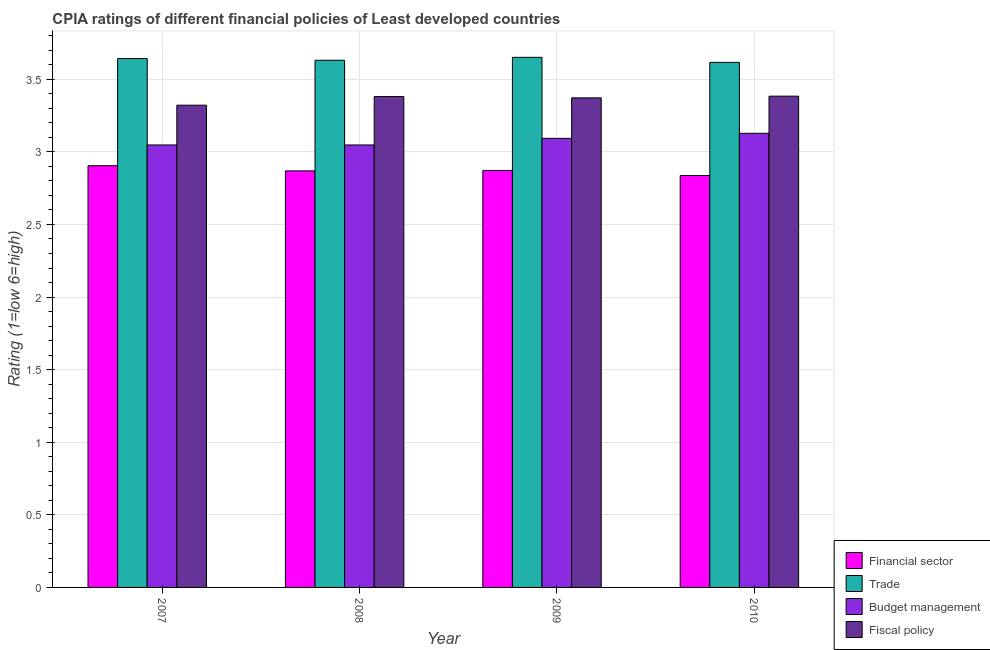How many different coloured bars are there?
Offer a very short reply. 4. How many groups of bars are there?
Your answer should be compact. 4. Are the number of bars per tick equal to the number of legend labels?
Offer a very short reply. Yes. How many bars are there on the 3rd tick from the right?
Ensure brevity in your answer.  4. What is the label of the 1st group of bars from the left?
Ensure brevity in your answer.  2007. What is the cpia rating of budget management in 2010?
Make the answer very short. 3.13. Across all years, what is the maximum cpia rating of financial sector?
Keep it short and to the point. 2.9. Across all years, what is the minimum cpia rating of fiscal policy?
Provide a succinct answer. 3.32. In which year was the cpia rating of trade minimum?
Make the answer very short. 2010. What is the total cpia rating of budget management in the graph?
Provide a short and direct response. 12.32. What is the difference between the cpia rating of budget management in 2008 and that in 2009?
Your answer should be very brief. -0.05. What is the difference between the cpia rating of trade in 2009 and the cpia rating of fiscal policy in 2010?
Keep it short and to the point. 0.03. What is the average cpia rating of trade per year?
Keep it short and to the point. 3.64. What is the ratio of the cpia rating of fiscal policy in 2008 to that in 2009?
Keep it short and to the point. 1. Is the difference between the cpia rating of trade in 2007 and 2009 greater than the difference between the cpia rating of financial sector in 2007 and 2009?
Your response must be concise. No. What is the difference between the highest and the second highest cpia rating of trade?
Offer a terse response. 0.01. What is the difference between the highest and the lowest cpia rating of fiscal policy?
Offer a terse response. 0.06. Is it the case that in every year, the sum of the cpia rating of fiscal policy and cpia rating of trade is greater than the sum of cpia rating of financial sector and cpia rating of budget management?
Offer a very short reply. No. What does the 2nd bar from the left in 2007 represents?
Give a very brief answer. Trade. What does the 2nd bar from the right in 2008 represents?
Offer a very short reply. Budget management. Are all the bars in the graph horizontal?
Offer a very short reply. No. What is the difference between two consecutive major ticks on the Y-axis?
Provide a succinct answer. 0.5. Does the graph contain grids?
Provide a short and direct response. Yes. What is the title of the graph?
Offer a very short reply. CPIA ratings of different financial policies of Least developed countries. Does "Pre-primary schools" appear as one of the legend labels in the graph?
Provide a short and direct response. No. What is the label or title of the Y-axis?
Your answer should be very brief. Rating (1=low 6=high). What is the Rating (1=low 6=high) of Financial sector in 2007?
Offer a very short reply. 2.9. What is the Rating (1=low 6=high) in Trade in 2007?
Provide a succinct answer. 3.64. What is the Rating (1=low 6=high) in Budget management in 2007?
Provide a succinct answer. 3.05. What is the Rating (1=low 6=high) of Fiscal policy in 2007?
Your answer should be very brief. 3.32. What is the Rating (1=low 6=high) in Financial sector in 2008?
Make the answer very short. 2.87. What is the Rating (1=low 6=high) in Trade in 2008?
Your answer should be compact. 3.63. What is the Rating (1=low 6=high) in Budget management in 2008?
Keep it short and to the point. 3.05. What is the Rating (1=low 6=high) in Fiscal policy in 2008?
Ensure brevity in your answer.  3.38. What is the Rating (1=low 6=high) in Financial sector in 2009?
Your answer should be compact. 2.87. What is the Rating (1=low 6=high) of Trade in 2009?
Ensure brevity in your answer.  3.65. What is the Rating (1=low 6=high) of Budget management in 2009?
Your response must be concise. 3.09. What is the Rating (1=low 6=high) in Fiscal policy in 2009?
Offer a terse response. 3.37. What is the Rating (1=low 6=high) in Financial sector in 2010?
Your answer should be very brief. 2.84. What is the Rating (1=low 6=high) in Trade in 2010?
Offer a very short reply. 3.62. What is the Rating (1=low 6=high) of Budget management in 2010?
Your response must be concise. 3.13. What is the Rating (1=low 6=high) in Fiscal policy in 2010?
Make the answer very short. 3.38. Across all years, what is the maximum Rating (1=low 6=high) of Financial sector?
Offer a terse response. 2.9. Across all years, what is the maximum Rating (1=low 6=high) of Trade?
Offer a very short reply. 3.65. Across all years, what is the maximum Rating (1=low 6=high) of Budget management?
Your response must be concise. 3.13. Across all years, what is the maximum Rating (1=low 6=high) of Fiscal policy?
Offer a very short reply. 3.38. Across all years, what is the minimum Rating (1=low 6=high) in Financial sector?
Keep it short and to the point. 2.84. Across all years, what is the minimum Rating (1=low 6=high) in Trade?
Keep it short and to the point. 3.62. Across all years, what is the minimum Rating (1=low 6=high) in Budget management?
Your answer should be very brief. 3.05. Across all years, what is the minimum Rating (1=low 6=high) of Fiscal policy?
Make the answer very short. 3.32. What is the total Rating (1=low 6=high) of Financial sector in the graph?
Provide a succinct answer. 11.48. What is the total Rating (1=low 6=high) of Trade in the graph?
Provide a short and direct response. 14.54. What is the total Rating (1=low 6=high) in Budget management in the graph?
Your answer should be very brief. 12.32. What is the total Rating (1=low 6=high) of Fiscal policy in the graph?
Your answer should be compact. 13.46. What is the difference between the Rating (1=low 6=high) in Financial sector in 2007 and that in 2008?
Ensure brevity in your answer.  0.04. What is the difference between the Rating (1=low 6=high) in Trade in 2007 and that in 2008?
Provide a succinct answer. 0.01. What is the difference between the Rating (1=low 6=high) in Budget management in 2007 and that in 2008?
Offer a terse response. 0. What is the difference between the Rating (1=low 6=high) in Fiscal policy in 2007 and that in 2008?
Your answer should be very brief. -0.06. What is the difference between the Rating (1=low 6=high) in Financial sector in 2007 and that in 2009?
Your response must be concise. 0.03. What is the difference between the Rating (1=low 6=high) of Trade in 2007 and that in 2009?
Give a very brief answer. -0.01. What is the difference between the Rating (1=low 6=high) of Budget management in 2007 and that in 2009?
Ensure brevity in your answer.  -0.05. What is the difference between the Rating (1=low 6=high) in Fiscal policy in 2007 and that in 2009?
Provide a succinct answer. -0.05. What is the difference between the Rating (1=low 6=high) of Financial sector in 2007 and that in 2010?
Your answer should be compact. 0.07. What is the difference between the Rating (1=low 6=high) in Trade in 2007 and that in 2010?
Provide a short and direct response. 0.03. What is the difference between the Rating (1=low 6=high) in Budget management in 2007 and that in 2010?
Your answer should be compact. -0.08. What is the difference between the Rating (1=low 6=high) of Fiscal policy in 2007 and that in 2010?
Your answer should be compact. -0.06. What is the difference between the Rating (1=low 6=high) of Financial sector in 2008 and that in 2009?
Provide a succinct answer. -0. What is the difference between the Rating (1=low 6=high) of Trade in 2008 and that in 2009?
Provide a short and direct response. -0.02. What is the difference between the Rating (1=low 6=high) of Budget management in 2008 and that in 2009?
Offer a terse response. -0.05. What is the difference between the Rating (1=low 6=high) in Fiscal policy in 2008 and that in 2009?
Give a very brief answer. 0.01. What is the difference between the Rating (1=low 6=high) in Financial sector in 2008 and that in 2010?
Offer a very short reply. 0.03. What is the difference between the Rating (1=low 6=high) of Trade in 2008 and that in 2010?
Keep it short and to the point. 0.01. What is the difference between the Rating (1=low 6=high) in Budget management in 2008 and that in 2010?
Your response must be concise. -0.08. What is the difference between the Rating (1=low 6=high) in Fiscal policy in 2008 and that in 2010?
Give a very brief answer. -0. What is the difference between the Rating (1=low 6=high) in Financial sector in 2009 and that in 2010?
Make the answer very short. 0.03. What is the difference between the Rating (1=low 6=high) of Trade in 2009 and that in 2010?
Your response must be concise. 0.03. What is the difference between the Rating (1=low 6=high) in Budget management in 2009 and that in 2010?
Your answer should be compact. -0.03. What is the difference between the Rating (1=low 6=high) of Fiscal policy in 2009 and that in 2010?
Provide a succinct answer. -0.01. What is the difference between the Rating (1=low 6=high) of Financial sector in 2007 and the Rating (1=low 6=high) of Trade in 2008?
Keep it short and to the point. -0.73. What is the difference between the Rating (1=low 6=high) of Financial sector in 2007 and the Rating (1=low 6=high) of Budget management in 2008?
Keep it short and to the point. -0.14. What is the difference between the Rating (1=low 6=high) of Financial sector in 2007 and the Rating (1=low 6=high) of Fiscal policy in 2008?
Your answer should be very brief. -0.48. What is the difference between the Rating (1=low 6=high) of Trade in 2007 and the Rating (1=low 6=high) of Budget management in 2008?
Give a very brief answer. 0.6. What is the difference between the Rating (1=low 6=high) in Trade in 2007 and the Rating (1=low 6=high) in Fiscal policy in 2008?
Provide a short and direct response. 0.26. What is the difference between the Rating (1=low 6=high) of Budget management in 2007 and the Rating (1=low 6=high) of Fiscal policy in 2008?
Provide a short and direct response. -0.33. What is the difference between the Rating (1=low 6=high) in Financial sector in 2007 and the Rating (1=low 6=high) in Trade in 2009?
Your answer should be very brief. -0.75. What is the difference between the Rating (1=low 6=high) of Financial sector in 2007 and the Rating (1=low 6=high) of Budget management in 2009?
Provide a short and direct response. -0.19. What is the difference between the Rating (1=low 6=high) of Financial sector in 2007 and the Rating (1=low 6=high) of Fiscal policy in 2009?
Your response must be concise. -0.47. What is the difference between the Rating (1=low 6=high) in Trade in 2007 and the Rating (1=low 6=high) in Budget management in 2009?
Your answer should be compact. 0.55. What is the difference between the Rating (1=low 6=high) of Trade in 2007 and the Rating (1=low 6=high) of Fiscal policy in 2009?
Keep it short and to the point. 0.27. What is the difference between the Rating (1=low 6=high) in Budget management in 2007 and the Rating (1=low 6=high) in Fiscal policy in 2009?
Your answer should be very brief. -0.32. What is the difference between the Rating (1=low 6=high) of Financial sector in 2007 and the Rating (1=low 6=high) of Trade in 2010?
Give a very brief answer. -0.71. What is the difference between the Rating (1=low 6=high) in Financial sector in 2007 and the Rating (1=low 6=high) in Budget management in 2010?
Make the answer very short. -0.22. What is the difference between the Rating (1=low 6=high) of Financial sector in 2007 and the Rating (1=low 6=high) of Fiscal policy in 2010?
Your response must be concise. -0.48. What is the difference between the Rating (1=low 6=high) of Trade in 2007 and the Rating (1=low 6=high) of Budget management in 2010?
Provide a succinct answer. 0.52. What is the difference between the Rating (1=low 6=high) in Trade in 2007 and the Rating (1=low 6=high) in Fiscal policy in 2010?
Make the answer very short. 0.26. What is the difference between the Rating (1=low 6=high) of Budget management in 2007 and the Rating (1=low 6=high) of Fiscal policy in 2010?
Your response must be concise. -0.34. What is the difference between the Rating (1=low 6=high) in Financial sector in 2008 and the Rating (1=low 6=high) in Trade in 2009?
Offer a terse response. -0.78. What is the difference between the Rating (1=low 6=high) of Financial sector in 2008 and the Rating (1=low 6=high) of Budget management in 2009?
Make the answer very short. -0.22. What is the difference between the Rating (1=low 6=high) of Financial sector in 2008 and the Rating (1=low 6=high) of Fiscal policy in 2009?
Offer a terse response. -0.5. What is the difference between the Rating (1=low 6=high) in Trade in 2008 and the Rating (1=low 6=high) in Budget management in 2009?
Your answer should be very brief. 0.54. What is the difference between the Rating (1=low 6=high) of Trade in 2008 and the Rating (1=low 6=high) of Fiscal policy in 2009?
Offer a very short reply. 0.26. What is the difference between the Rating (1=low 6=high) of Budget management in 2008 and the Rating (1=low 6=high) of Fiscal policy in 2009?
Offer a very short reply. -0.32. What is the difference between the Rating (1=low 6=high) of Financial sector in 2008 and the Rating (1=low 6=high) of Trade in 2010?
Give a very brief answer. -0.75. What is the difference between the Rating (1=low 6=high) of Financial sector in 2008 and the Rating (1=low 6=high) of Budget management in 2010?
Keep it short and to the point. -0.26. What is the difference between the Rating (1=low 6=high) in Financial sector in 2008 and the Rating (1=low 6=high) in Fiscal policy in 2010?
Give a very brief answer. -0.51. What is the difference between the Rating (1=low 6=high) of Trade in 2008 and the Rating (1=low 6=high) of Budget management in 2010?
Your answer should be very brief. 0.5. What is the difference between the Rating (1=low 6=high) of Trade in 2008 and the Rating (1=low 6=high) of Fiscal policy in 2010?
Offer a terse response. 0.25. What is the difference between the Rating (1=low 6=high) in Budget management in 2008 and the Rating (1=low 6=high) in Fiscal policy in 2010?
Offer a terse response. -0.34. What is the difference between the Rating (1=low 6=high) of Financial sector in 2009 and the Rating (1=low 6=high) of Trade in 2010?
Offer a terse response. -0.74. What is the difference between the Rating (1=low 6=high) of Financial sector in 2009 and the Rating (1=low 6=high) of Budget management in 2010?
Your answer should be compact. -0.26. What is the difference between the Rating (1=low 6=high) of Financial sector in 2009 and the Rating (1=low 6=high) of Fiscal policy in 2010?
Ensure brevity in your answer.  -0.51. What is the difference between the Rating (1=low 6=high) of Trade in 2009 and the Rating (1=low 6=high) of Budget management in 2010?
Your response must be concise. 0.52. What is the difference between the Rating (1=low 6=high) in Trade in 2009 and the Rating (1=low 6=high) in Fiscal policy in 2010?
Your answer should be very brief. 0.27. What is the difference between the Rating (1=low 6=high) of Budget management in 2009 and the Rating (1=low 6=high) of Fiscal policy in 2010?
Offer a terse response. -0.29. What is the average Rating (1=low 6=high) of Financial sector per year?
Your answer should be compact. 2.87. What is the average Rating (1=low 6=high) in Trade per year?
Give a very brief answer. 3.64. What is the average Rating (1=low 6=high) of Budget management per year?
Give a very brief answer. 3.08. What is the average Rating (1=low 6=high) of Fiscal policy per year?
Provide a succinct answer. 3.36. In the year 2007, what is the difference between the Rating (1=low 6=high) of Financial sector and Rating (1=low 6=high) of Trade?
Offer a terse response. -0.74. In the year 2007, what is the difference between the Rating (1=low 6=high) of Financial sector and Rating (1=low 6=high) of Budget management?
Your response must be concise. -0.14. In the year 2007, what is the difference between the Rating (1=low 6=high) of Financial sector and Rating (1=low 6=high) of Fiscal policy?
Your response must be concise. -0.42. In the year 2007, what is the difference between the Rating (1=low 6=high) of Trade and Rating (1=low 6=high) of Budget management?
Make the answer very short. 0.6. In the year 2007, what is the difference between the Rating (1=low 6=high) in Trade and Rating (1=low 6=high) in Fiscal policy?
Your response must be concise. 0.32. In the year 2007, what is the difference between the Rating (1=low 6=high) of Budget management and Rating (1=low 6=high) of Fiscal policy?
Your answer should be compact. -0.27. In the year 2008, what is the difference between the Rating (1=low 6=high) in Financial sector and Rating (1=low 6=high) in Trade?
Offer a very short reply. -0.76. In the year 2008, what is the difference between the Rating (1=low 6=high) of Financial sector and Rating (1=low 6=high) of Budget management?
Make the answer very short. -0.18. In the year 2008, what is the difference between the Rating (1=low 6=high) in Financial sector and Rating (1=low 6=high) in Fiscal policy?
Offer a very short reply. -0.51. In the year 2008, what is the difference between the Rating (1=low 6=high) of Trade and Rating (1=low 6=high) of Budget management?
Keep it short and to the point. 0.58. In the year 2008, what is the difference between the Rating (1=low 6=high) of Budget management and Rating (1=low 6=high) of Fiscal policy?
Give a very brief answer. -0.33. In the year 2009, what is the difference between the Rating (1=low 6=high) in Financial sector and Rating (1=low 6=high) in Trade?
Offer a terse response. -0.78. In the year 2009, what is the difference between the Rating (1=low 6=high) in Financial sector and Rating (1=low 6=high) in Budget management?
Offer a very short reply. -0.22. In the year 2009, what is the difference between the Rating (1=low 6=high) in Trade and Rating (1=low 6=high) in Budget management?
Offer a terse response. 0.56. In the year 2009, what is the difference between the Rating (1=low 6=high) in Trade and Rating (1=low 6=high) in Fiscal policy?
Ensure brevity in your answer.  0.28. In the year 2009, what is the difference between the Rating (1=low 6=high) of Budget management and Rating (1=low 6=high) of Fiscal policy?
Offer a terse response. -0.28. In the year 2010, what is the difference between the Rating (1=low 6=high) in Financial sector and Rating (1=low 6=high) in Trade?
Your answer should be compact. -0.78. In the year 2010, what is the difference between the Rating (1=low 6=high) in Financial sector and Rating (1=low 6=high) in Budget management?
Provide a short and direct response. -0.29. In the year 2010, what is the difference between the Rating (1=low 6=high) in Financial sector and Rating (1=low 6=high) in Fiscal policy?
Provide a succinct answer. -0.55. In the year 2010, what is the difference between the Rating (1=low 6=high) in Trade and Rating (1=low 6=high) in Budget management?
Make the answer very short. 0.49. In the year 2010, what is the difference between the Rating (1=low 6=high) in Trade and Rating (1=low 6=high) in Fiscal policy?
Give a very brief answer. 0.23. In the year 2010, what is the difference between the Rating (1=low 6=high) of Budget management and Rating (1=low 6=high) of Fiscal policy?
Provide a succinct answer. -0.26. What is the ratio of the Rating (1=low 6=high) of Financial sector in 2007 to that in 2008?
Ensure brevity in your answer.  1.01. What is the ratio of the Rating (1=low 6=high) of Trade in 2007 to that in 2008?
Offer a very short reply. 1. What is the ratio of the Rating (1=low 6=high) of Budget management in 2007 to that in 2008?
Your answer should be very brief. 1. What is the ratio of the Rating (1=low 6=high) in Fiscal policy in 2007 to that in 2008?
Offer a very short reply. 0.98. What is the ratio of the Rating (1=low 6=high) in Financial sector in 2007 to that in 2009?
Your answer should be very brief. 1.01. What is the ratio of the Rating (1=low 6=high) in Trade in 2007 to that in 2009?
Give a very brief answer. 1. What is the ratio of the Rating (1=low 6=high) in Budget management in 2007 to that in 2009?
Give a very brief answer. 0.99. What is the ratio of the Rating (1=low 6=high) of Financial sector in 2007 to that in 2010?
Your answer should be compact. 1.02. What is the ratio of the Rating (1=low 6=high) of Trade in 2007 to that in 2010?
Keep it short and to the point. 1.01. What is the ratio of the Rating (1=low 6=high) in Budget management in 2007 to that in 2010?
Provide a short and direct response. 0.97. What is the ratio of the Rating (1=low 6=high) in Fiscal policy in 2007 to that in 2010?
Ensure brevity in your answer.  0.98. What is the ratio of the Rating (1=low 6=high) in Budget management in 2008 to that in 2009?
Offer a very short reply. 0.99. What is the ratio of the Rating (1=low 6=high) in Fiscal policy in 2008 to that in 2009?
Your answer should be very brief. 1. What is the ratio of the Rating (1=low 6=high) in Financial sector in 2008 to that in 2010?
Offer a very short reply. 1.01. What is the ratio of the Rating (1=low 6=high) in Budget management in 2008 to that in 2010?
Make the answer very short. 0.97. What is the ratio of the Rating (1=low 6=high) of Fiscal policy in 2008 to that in 2010?
Your response must be concise. 1. What is the ratio of the Rating (1=low 6=high) of Financial sector in 2009 to that in 2010?
Give a very brief answer. 1.01. What is the ratio of the Rating (1=low 6=high) of Trade in 2009 to that in 2010?
Make the answer very short. 1.01. What is the ratio of the Rating (1=low 6=high) of Fiscal policy in 2009 to that in 2010?
Provide a short and direct response. 1. What is the difference between the highest and the second highest Rating (1=low 6=high) in Financial sector?
Offer a very short reply. 0.03. What is the difference between the highest and the second highest Rating (1=low 6=high) in Trade?
Your response must be concise. 0.01. What is the difference between the highest and the second highest Rating (1=low 6=high) of Budget management?
Give a very brief answer. 0.03. What is the difference between the highest and the second highest Rating (1=low 6=high) of Fiscal policy?
Provide a short and direct response. 0. What is the difference between the highest and the lowest Rating (1=low 6=high) of Financial sector?
Offer a very short reply. 0.07. What is the difference between the highest and the lowest Rating (1=low 6=high) in Trade?
Make the answer very short. 0.03. What is the difference between the highest and the lowest Rating (1=low 6=high) of Budget management?
Provide a succinct answer. 0.08. What is the difference between the highest and the lowest Rating (1=low 6=high) in Fiscal policy?
Provide a succinct answer. 0.06. 